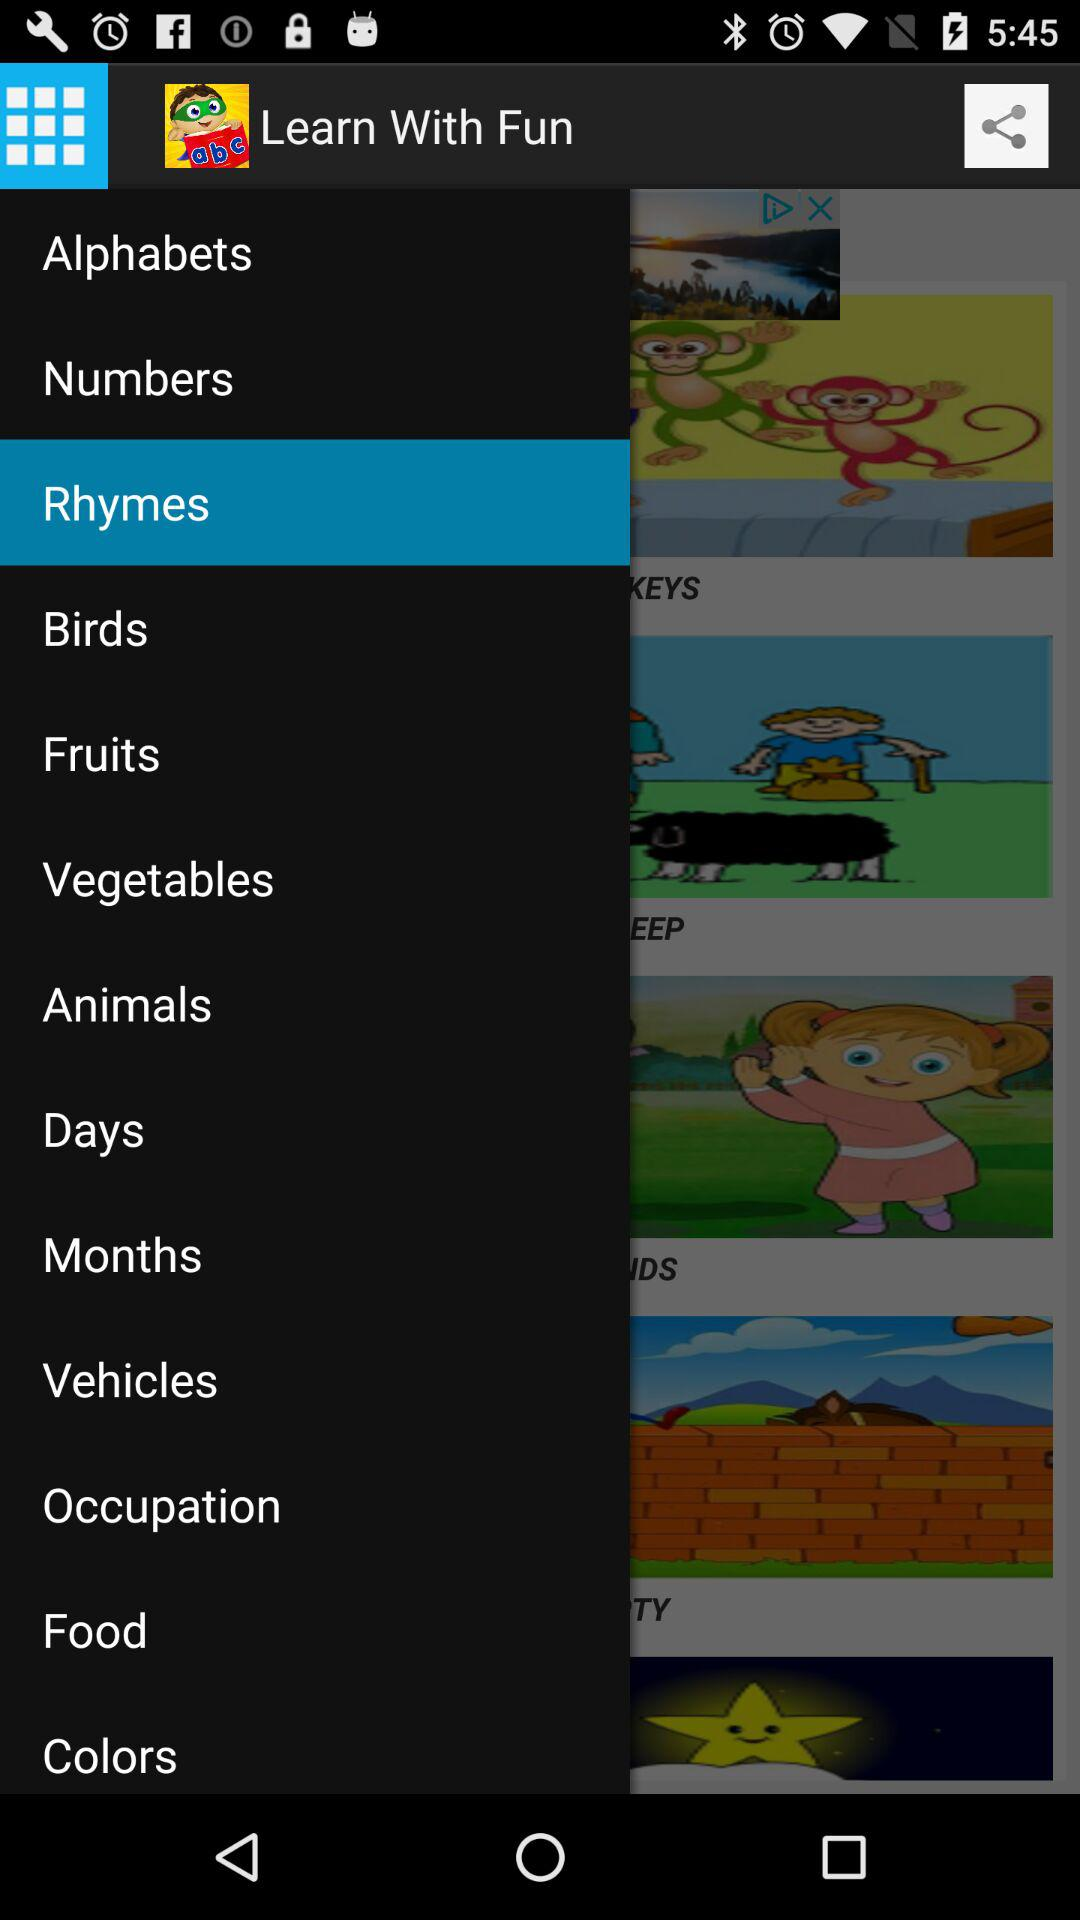What is the name of the application? The name of the application is "Learn With Fun". 